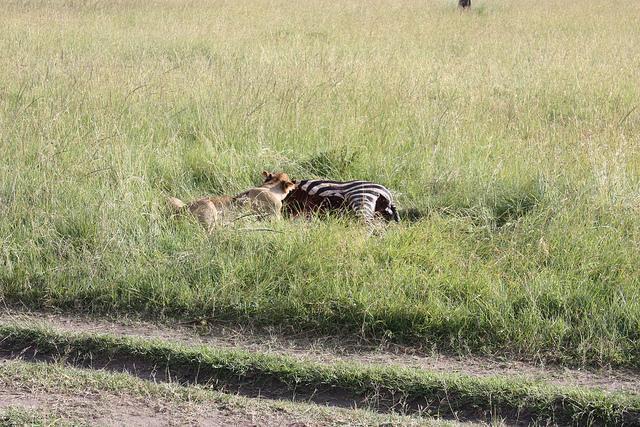How many cats are there?
Give a very brief answer. 1. 